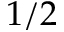<formula> <loc_0><loc_0><loc_500><loc_500>1 / 2</formula> 